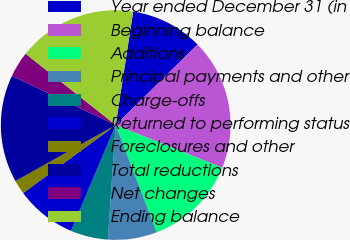Convert chart. <chart><loc_0><loc_0><loc_500><loc_500><pie_chart><fcel>Year ended December 31 (in<fcel>Beginning balance<fcel>Additions<fcel>Principal payments and other<fcel>Charge-offs<fcel>Returned to performing status<fcel>Foreclosures and other<fcel>Total reductions<fcel>Net changes<fcel>Ending balance<nl><fcel>10.2%<fcel>18.43%<fcel>13.12%<fcel>6.91%<fcel>5.27%<fcel>8.55%<fcel>1.98%<fcel>15.14%<fcel>3.62%<fcel>16.78%<nl></chart> 